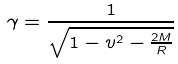Convert formula to latex. <formula><loc_0><loc_0><loc_500><loc_500>\gamma = \frac { 1 } { \sqrt { 1 - v ^ { 2 } - \frac { 2 M } { R } } }</formula> 